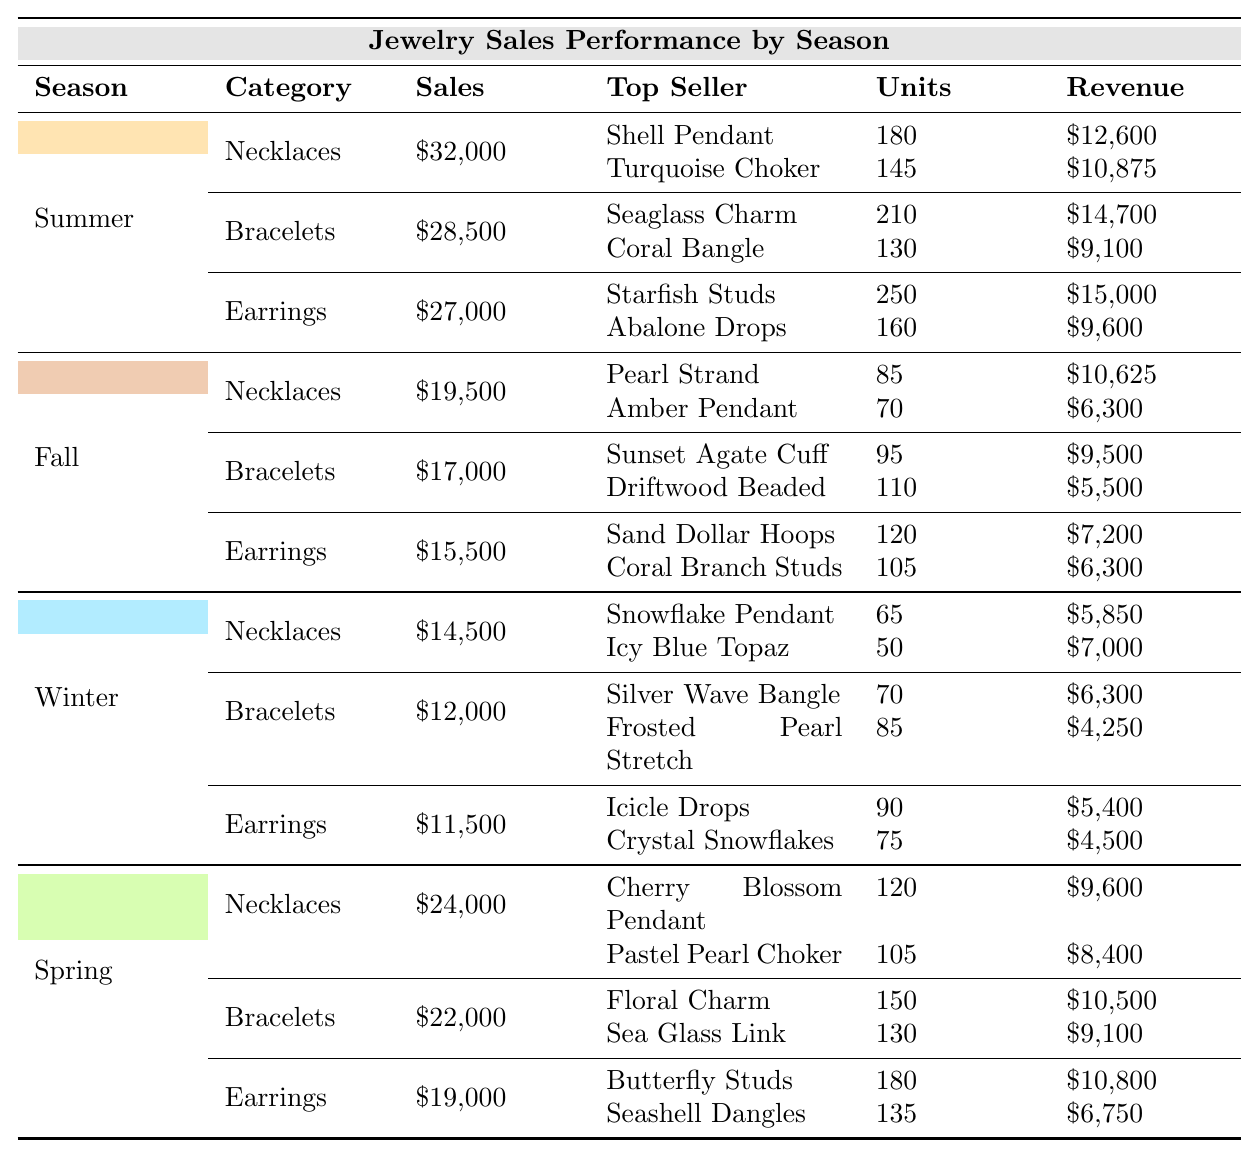What is the total sales amount for Summer? The table lists the total sales for Summer under "Total Sales," which is given as $87,500.
Answer: $87,500 What were the top-selling earrings in Winter? The table shows that the top-selling earrings in Winter were "Icicle Drops" with 90 units sold for a revenue of $5,400 and "Crystal Snowflakes" with 75 units at $4,500.
Answer: Icicle Drops Which season had the highest total sales? By comparing the total sales of each season, Summer has the highest total sales at $87,500, followed by Spring at $65,000, Fall at $52,000, and Winter at $38,000.
Answer: Summer How much did "Coral Bangle" generate in sales? The table indicates that "Coral Bangle" generated $9,100 in sales as its revenue is recorded next to its units sold under the Bracelets category in Summer.
Answer: $9,100 What is the total sales for Bracelets in Fall? The table shows that the total sales for Bracelets in Fall is $17,000. This is confirmed by referring to the sales data specifically for Bracelets under the Fall season.
Answer: $17,000 What is the difference in total sales between Spring and Winter? The total sales for Spring is $65,000 and Winter is $38,000. The difference is calculated as $65,000 - $38,000 = $27,000.
Answer: $27,000 Which season had the highest revenue from Necklaces? From the table, Summer had the highest sales in Necklaces at $32,000, followed by Spring at $24,000, Fall at $19,500, and Winter at $14,500.
Answer: Summer What is the average sales across all seasons for Earrings? Adding up the total sales for Earrings across all four seasons (Summer: $27,000, Fall: $15,500, Winter: $11,500, Spring: $19,000) gives $73,000. Dividing this by 4 seasons results in an average of $18,250 per season.
Answer: $18,250 Did any season have no sales in Necklaces? The table shows that every season has a recorded sales amount for Necklaces, so no season had zero sales for this category.
Answer: No Which category sold the most in Spring? In Spring, Bracelets generated the most sales at $22,000, compared to Necklaces at $24,000 and Earrings at $19,000, which makes Bracelets the top category.
Answer: Bracelets 